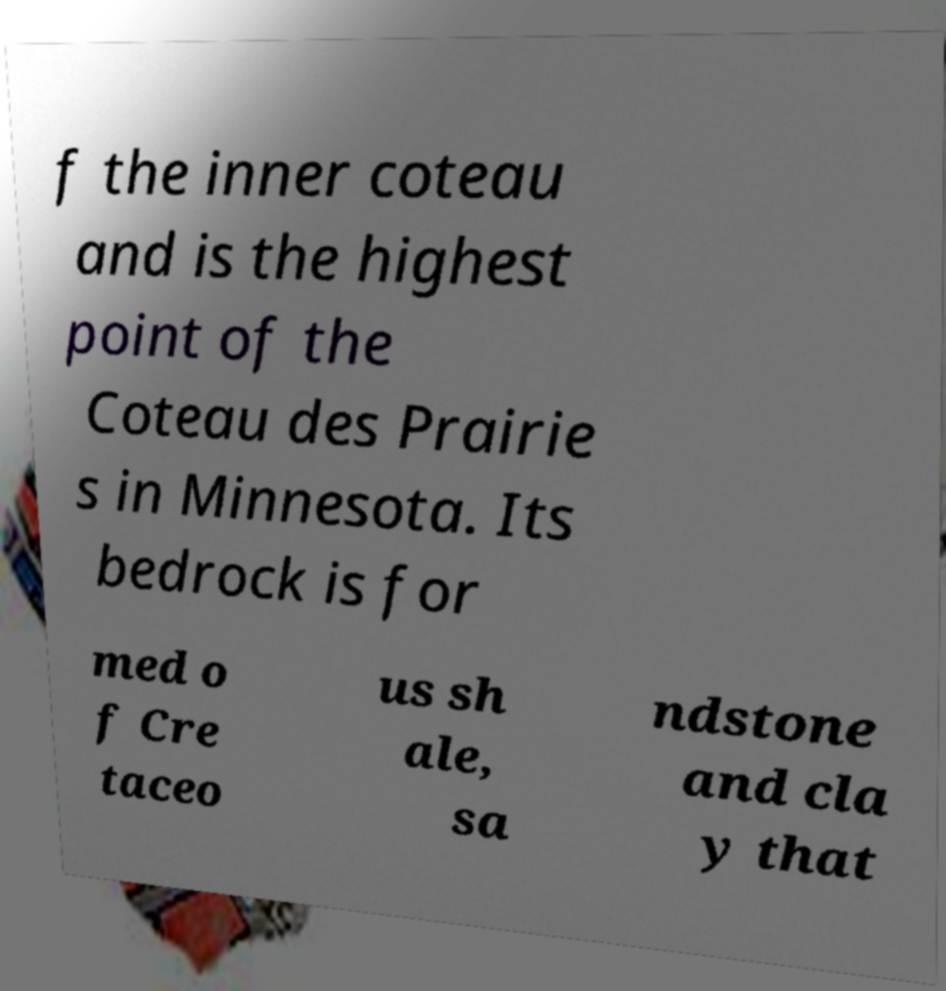Can you read and provide the text displayed in the image?This photo seems to have some interesting text. Can you extract and type it out for me? f the inner coteau and is the highest point of the Coteau des Prairie s in Minnesota. Its bedrock is for med o f Cre taceo us sh ale, sa ndstone and cla y that 